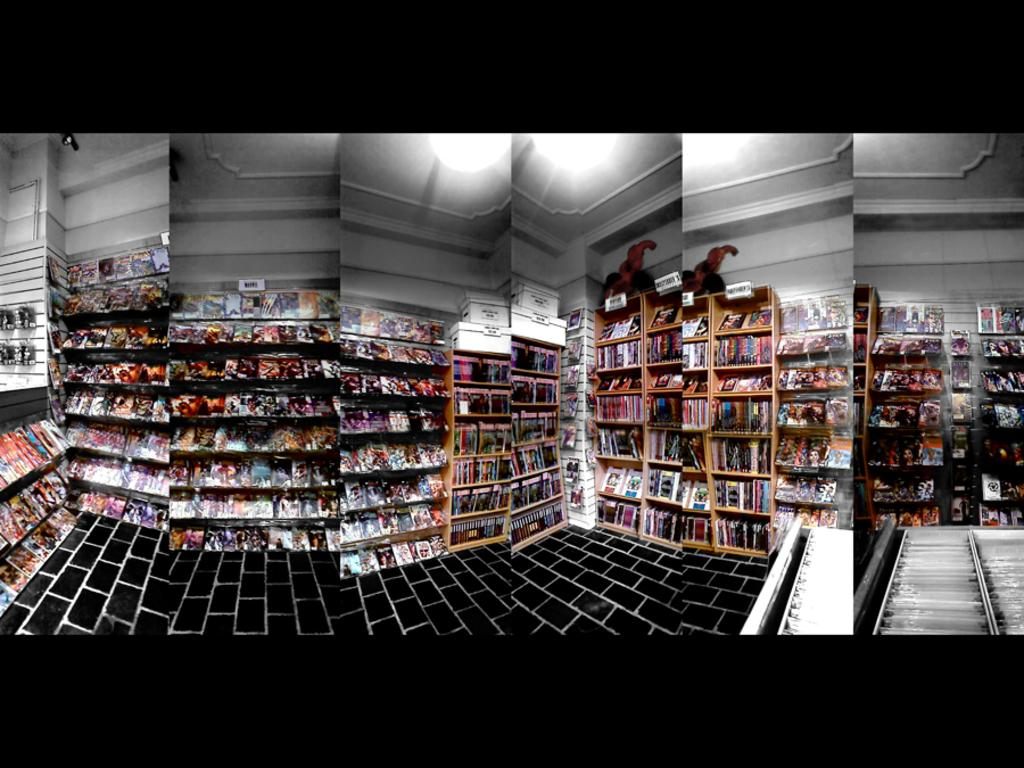What type of image is being described? The image is a collage of different pictures. What is a common feature in each picture? Each picture contains shelves. What are the shelves filled with? The shelves are filled with books. What type of stick can be seen connecting the dolls in the image? There are no dolls or sticks present in the image; it is a collage of pictures with shelves filled with books. 